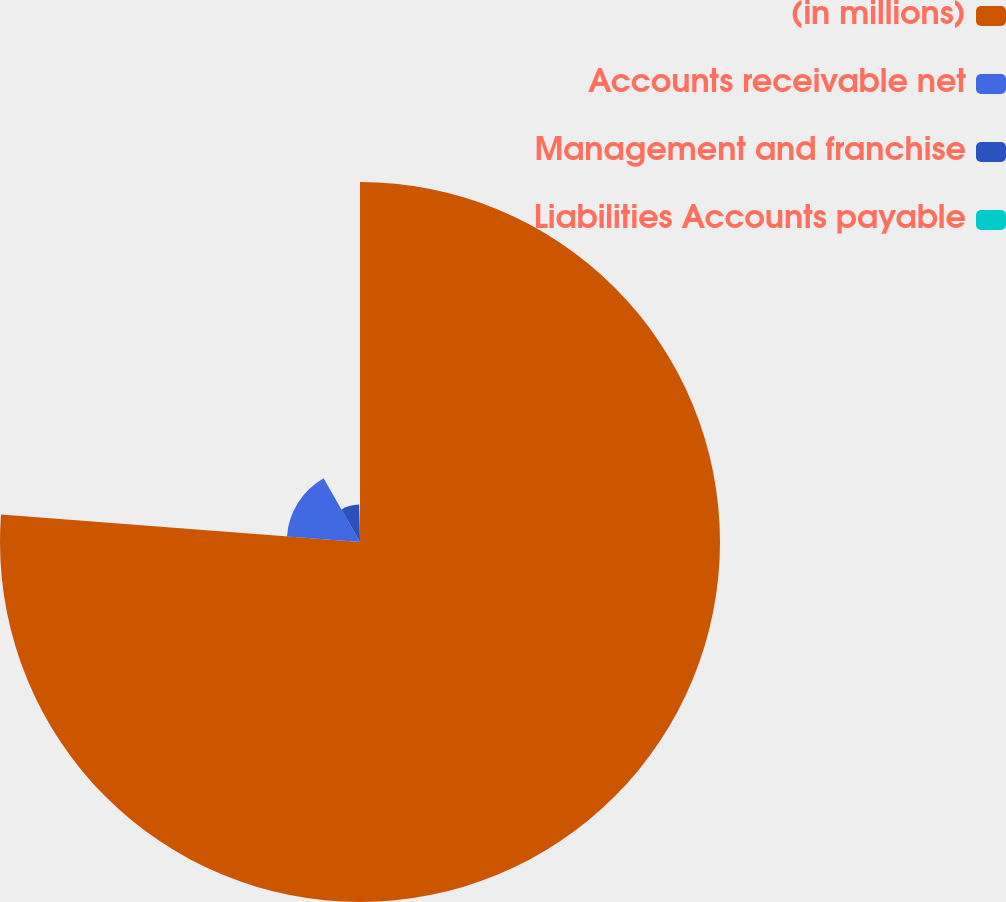Convert chart. <chart><loc_0><loc_0><loc_500><loc_500><pie_chart><fcel>(in millions)<fcel>Accounts receivable net<fcel>Management and franchise<fcel>Liabilities Accounts payable<nl><fcel>76.22%<fcel>15.52%<fcel>7.93%<fcel>0.34%<nl></chart> 